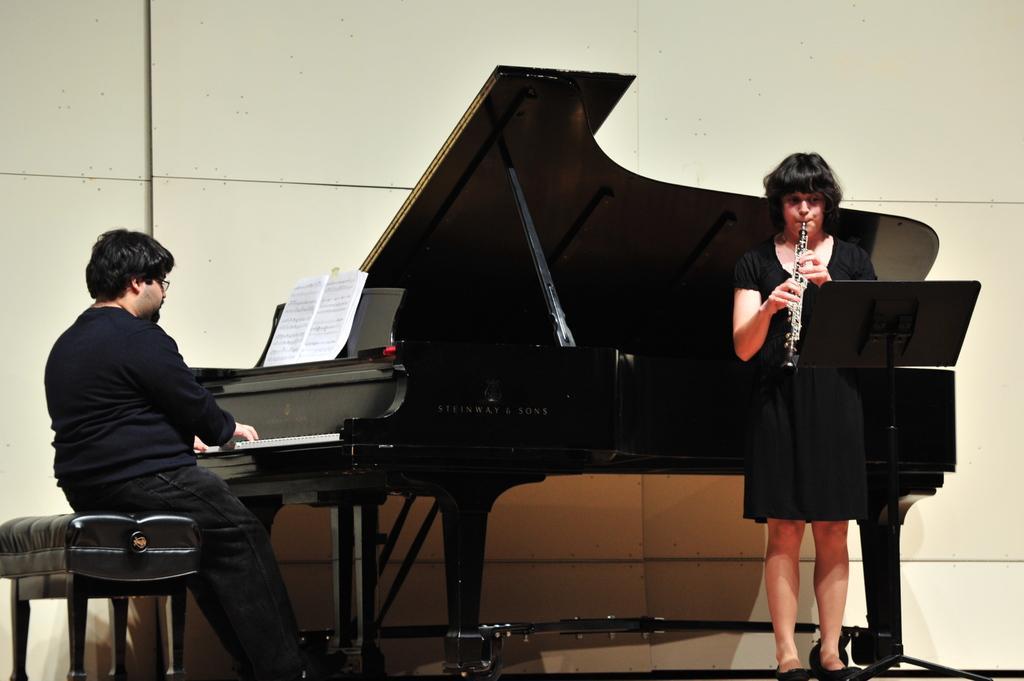Describe this image in one or two sentences. In the image there is a woman playing trumpet on right side, she wore black dress, on the left side there is a man sitting on sofa playing piano, behind them there is a wall. 